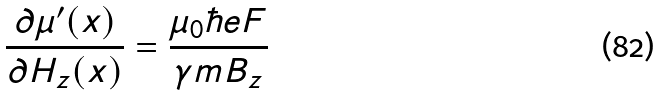Convert formula to latex. <formula><loc_0><loc_0><loc_500><loc_500>\frac { \partial \mu ^ { \prime } ( x ) } { \partial H _ { z } ( x ) } = \frac { \mu _ { 0 } \hbar { e } F } { \gamma m B _ { z } }</formula> 